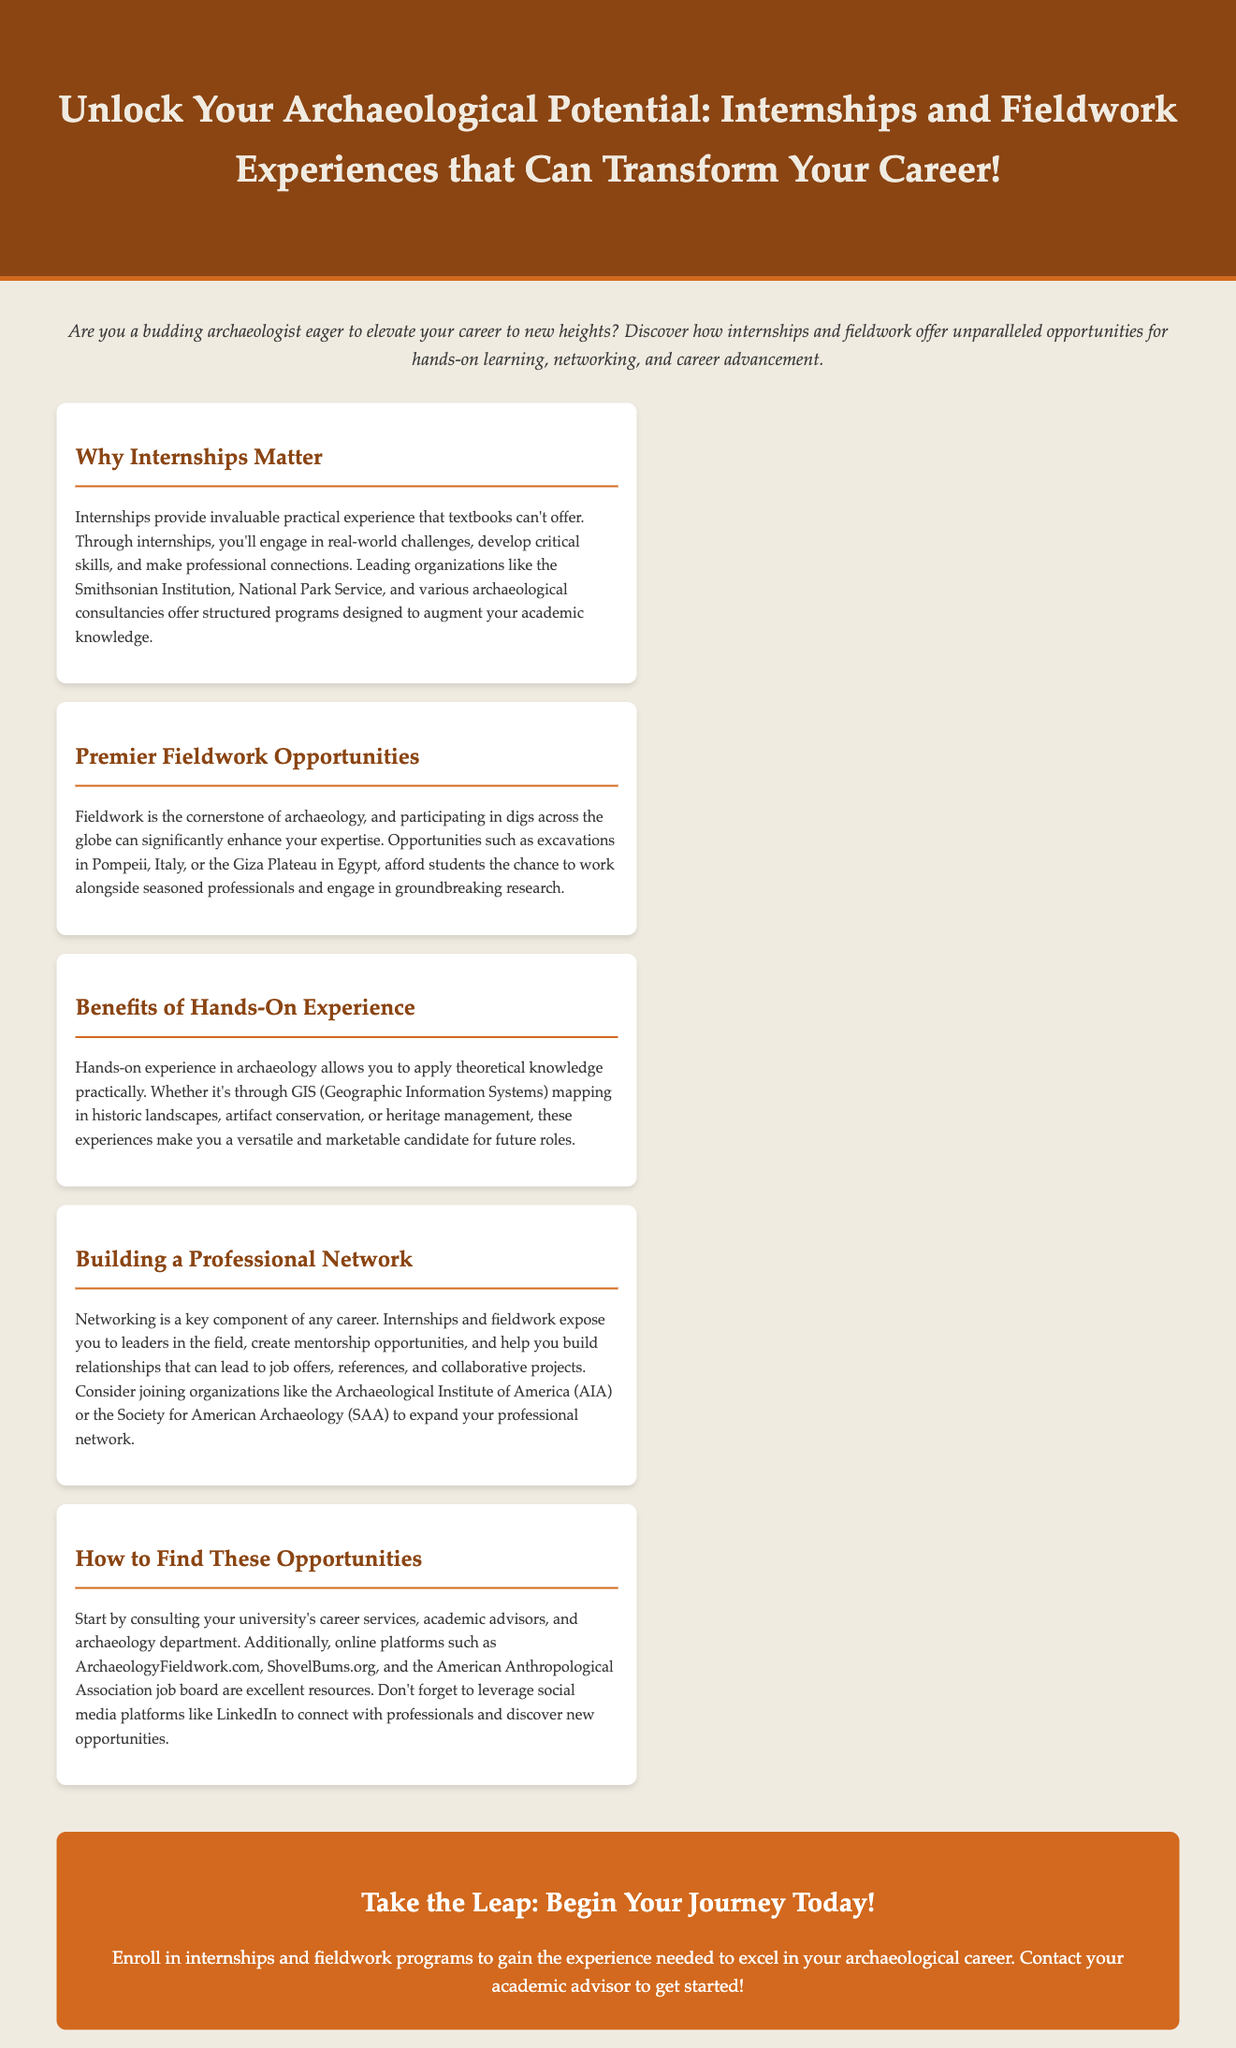What is the main title of the advertisement? The title provides the primary focus of the advertisement that invites the reader to engage in internships and fieldwork.
Answer: Unlock Your Archaeological Potential: Internships and Fieldwork Experiences that Can Transform Your Career! What organization is mentioned as a leading provider of internships? The document lists notable organizations that offer internships in archaeology, emphasizing their significance.
Answer: Smithsonian Institution Where can students find premier fieldwork opportunities? The document mentions specific renowned locations that offer fieldwork experiences for students engaged in archaeology.
Answer: Pompeii, Italy What are the benefits of hands-on experience in archaeology according to the advertisement? The document details specific advantages that such experiences provide for building a career in archaeology.
Answer: Versatile and marketable candidate Which organizations are suggested for expanding professional networks? The advertisement outlines specific organizations that students may join to enhance their professional relationships in archaeology.
Answer: Archaeological Institute of America (AIA) What online platform is recommended for discovering archaeology job opportunities? The advertisement specifies a website that serves as a resource for finding fieldwork and internship opportunities.
Answer: ArchaeologyFieldwork.com How can students start finding internships and fieldwork opportunities? The document highlights initial steps that students should take to find opportunities in the field of archaeology.
Answer: University’s career services What does the call to action encourage students to do? The conclusion of the advertisement contains a motivational statement urging students toward specific actions related to their careers.
Answer: Enroll in internships and fieldwork programs 